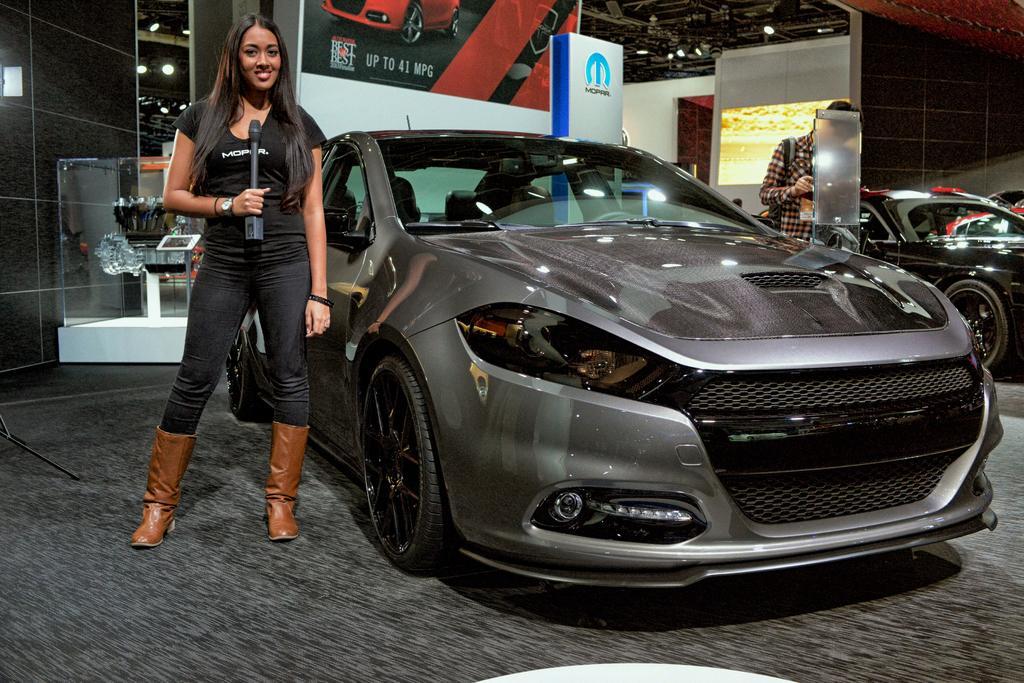Can you describe this image briefly? In the picture I can see a car on the floor. There is a woman on the left side and there is a smile on her face. She is wearing a black color T-shirt and she is holding a microphone in her right hand. I can see another car and a man on the right side. In the background, I can see the hoarding. There is a lighting arrangement on the roof. 